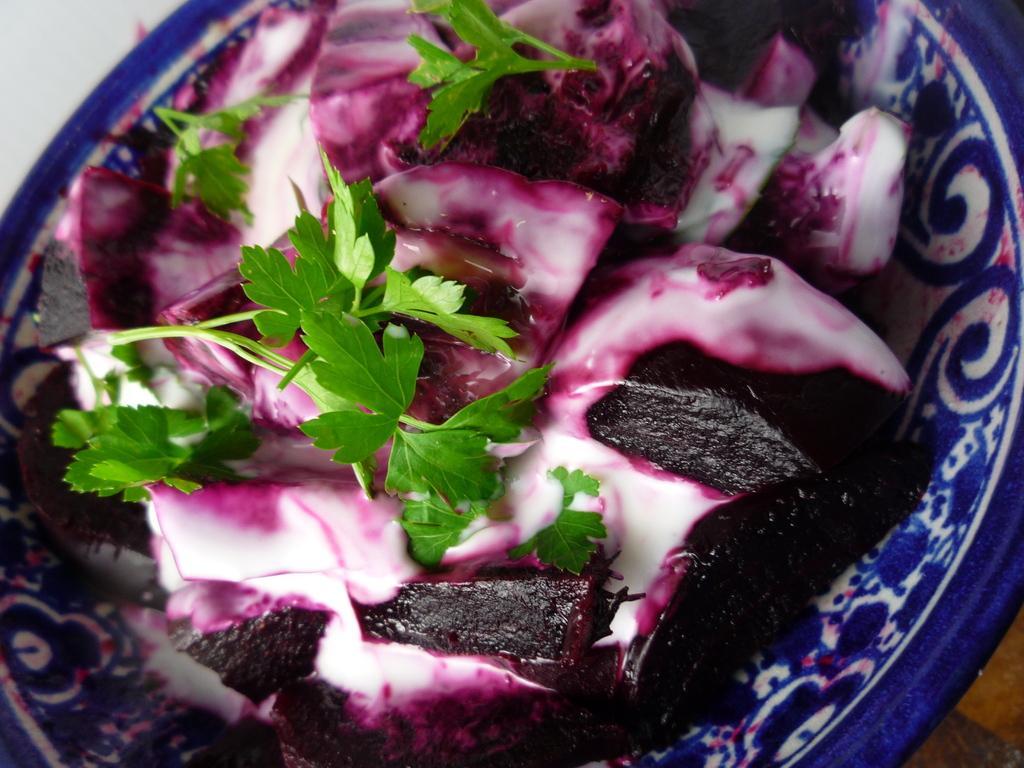Please provide a concise description of this image. In this picture I can see there is some food served in a bowl and there is some beetroot and coriander in the bowl. 